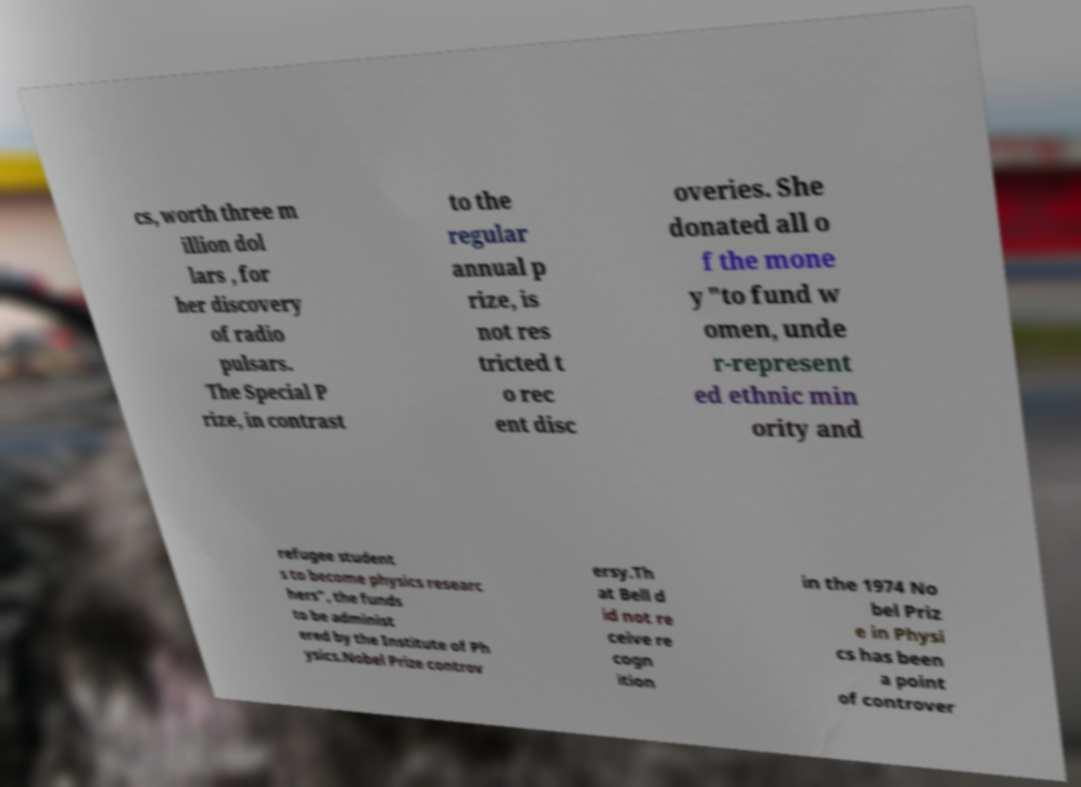Can you accurately transcribe the text from the provided image for me? cs, worth three m illion dol lars , for her discovery of radio pulsars. The Special P rize, in contrast to the regular annual p rize, is not res tricted t o rec ent disc overies. She donated all o f the mone y "to fund w omen, unde r-represent ed ethnic min ority and refugee student s to become physics researc hers", the funds to be administ ered by the Institute of Ph ysics.Nobel Prize controv ersy.Th at Bell d id not re ceive re cogn ition in the 1974 No bel Priz e in Physi cs has been a point of controver 